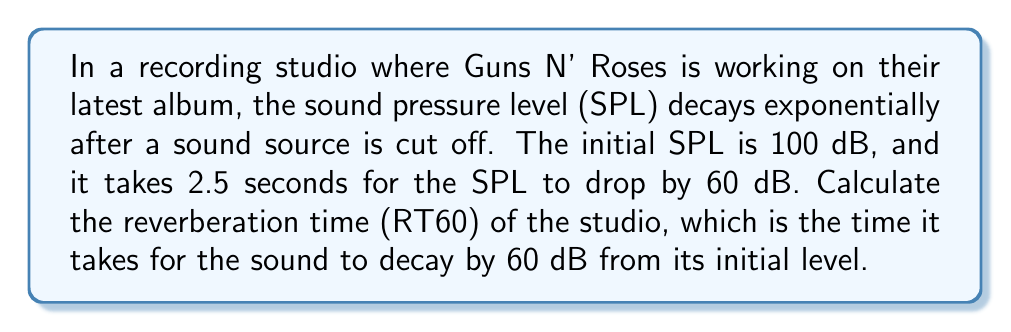Help me with this question. To solve this problem, we'll use the exponential decay model for sound pressure level:

$$SPL(t) = SPL_0 \cdot e^{-kt}$$

Where:
$SPL(t)$ is the sound pressure level at time $t$
$SPL_0$ is the initial sound pressure level
$k$ is the decay constant
$t$ is time

Step 1: Determine the decay constant $k$
We know that after 2.5 seconds, the SPL drops by 60 dB. This means:

$$SPL(2.5) = SPL_0 - 60$$

$$40 = 100 \cdot e^{-k \cdot 2.5}$$

Dividing both sides by 100:

$$0.4 = e^{-2.5k}$$

Taking the natural log of both sides:

$$\ln(0.4) = -2.5k$$

$$k = -\frac{\ln(0.4)}{2.5} \approx 0.3665$$

Step 2: Calculate RT60
RT60 is the time it takes for the sound to decay by 60 dB. We can use the same equation:

$$40 = 100 \cdot e^{-0.3665 \cdot RT60}$$

$$0.4 = e^{-0.3665 \cdot RT60}$$

$$\ln(0.4) = -0.3665 \cdot RT60$$

$$RT60 = -\frac{\ln(0.4)}{0.3665} \approx 2.5$$

Therefore, the reverberation time (RT60) of the studio is 2.5 seconds.
Answer: 2.5 seconds 